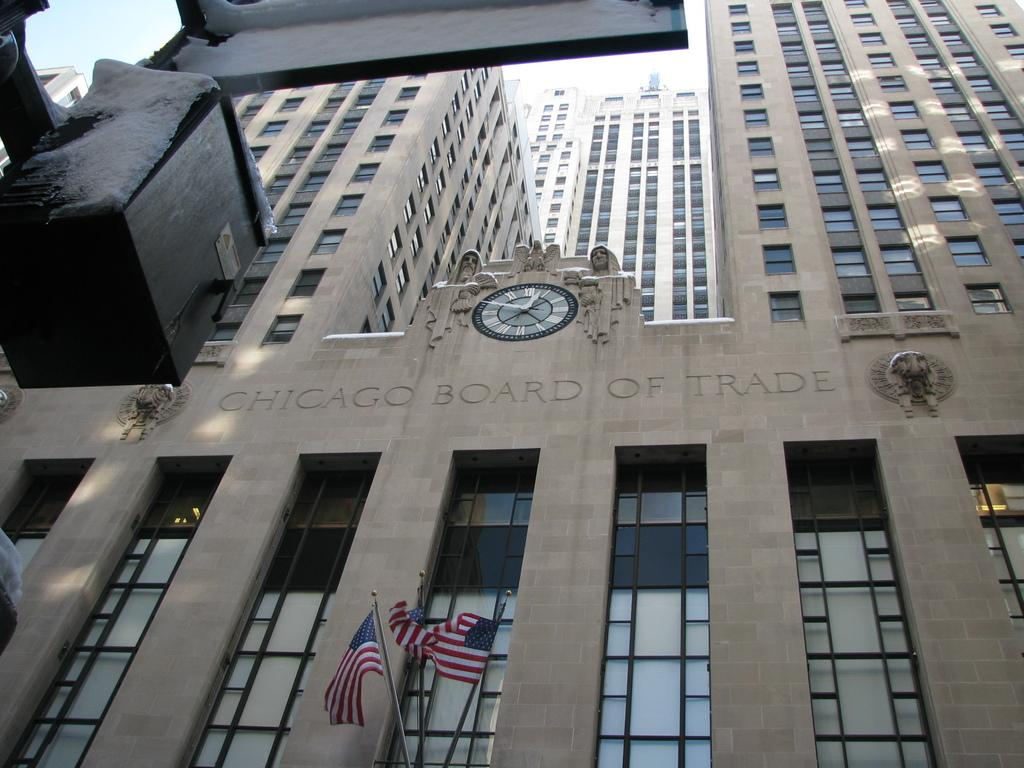What can be seen flying in the image? There are flags in the image. What type of structures are visible in the background? There are buildings in the background of the image. Is there any writing or text visible in the image? Yes, there is text written on the buildings. What type of nut is being used to sharpen the pencil in the image? There is no nut or pencil present in the image, so this question cannot be answered. 